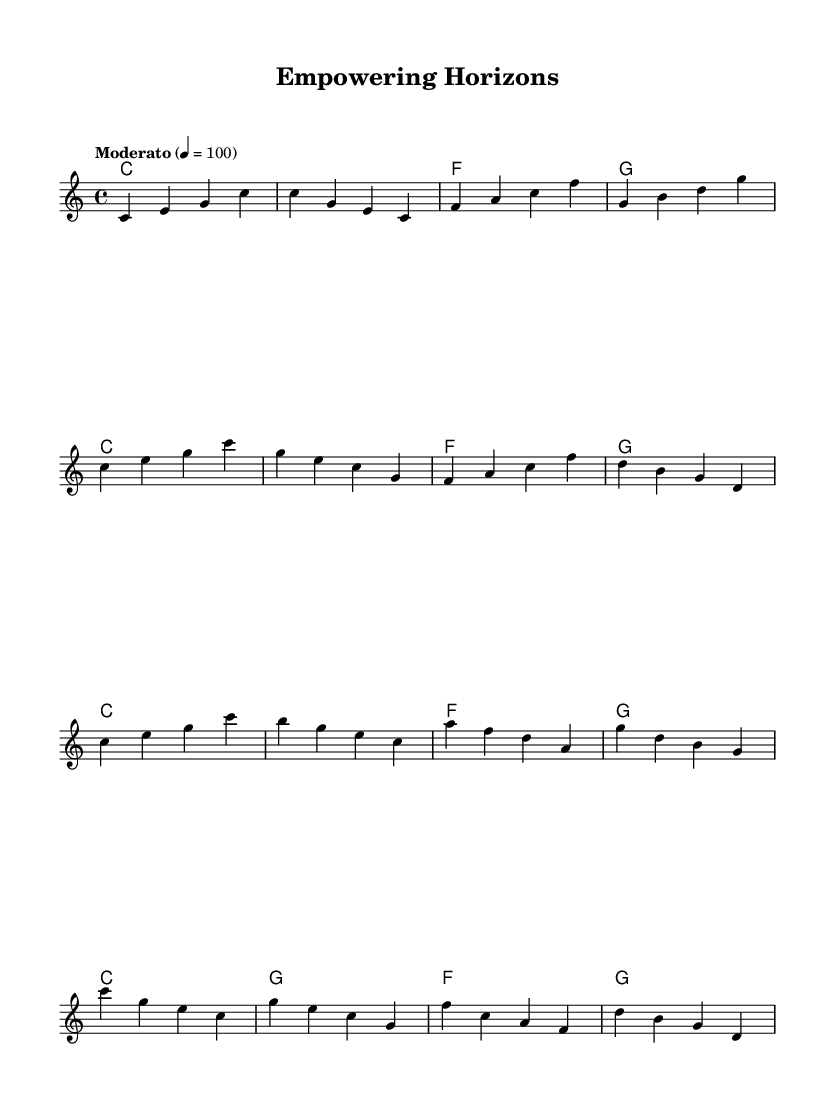What is the key signature of this music? The key signature is C major, which has no sharps or flats.
Answer: C major What is the time signature of this piece? The time signature indicated in the music is 4/4, which means there are four beats in each measure.
Answer: 4/4 What is the tempo marking for this piece? The tempo marking indicates "Moderato," which suggests a moderate tempo, specifically set at 100 beats per minute.
Answer: Moderato How many measures are in the introduction section? The introduction consists of four measures as seen in the first line of the sheet music.
Answer: 4 What is the first note of the melody? The first note in the melody is a C note, which is shown at the beginning of the music staff.
Answer: C How many times does the chord of C major appear in the harmonies? The chord of C major appears four times throughout the provided chord progression in the harmonies section.
Answer: 4 What is the primary emotional tone that this soundtrack aims to convey? The soundtrack aims to convey an uplifting emotional tone through its harmonious and melodic structure, which is characteristic of motivational music.
Answer: Uplifting 